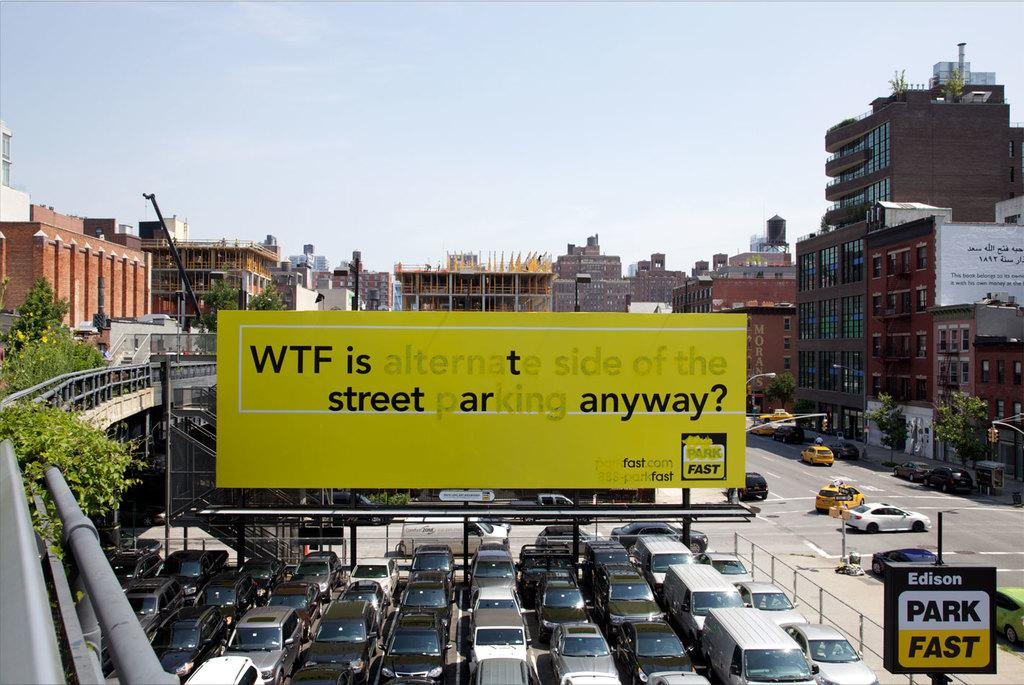Provide a one-sentence caption for the provided image. A large yellow sign that says WTF is alternate side of the street parking anyway. 